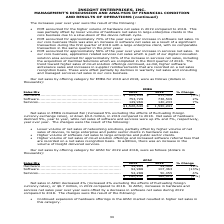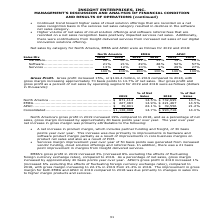From Insight Enterprises's financial document, What is the net sales of hardware in 2019 and 2018 respectively? The document shows two values: $34,965 and $29,496 (in thousands). From the document: "...................................... $ 34,965 $ 29,496 19% Software .................................................................. 92,988 107,36..." Also, What is the net sales of software in 2019 and 2018 respectively? The document shows two values: 92,988 and 107,363 (in thousands). From the document: "................................................. 92,988 107,363 (13%) Services................................................................... 52,..." Also, How much did net sales in decreased in 2019 compared to 2018? According to the financial document, $6.7 million. The relevant text states: "effects of fluctuating foreign currency rates), or $6.7 million, in 2019 compared to 2018. In APAC, increases in hardware and services net sales year over year wer..." Also, can you calculate: What is the change in Sales Mix of Hardware between 2018 and 2019? Based on the calculation: 34,965-29,496, the result is 5469 (in thousands). This is based on the information: "............................................... $ 34,965 $ 29,496 19% Software .................................................................. 92,988 107 ...................................... $ 34..." The key data points involved are: 29,496, 34,965. Also, can you calculate: What is the change in Sales Mix of Software between 2018 and 2019? Based on the calculation: 92,988-107,363, the result is -14375 (in thousands). This is based on the information: "................................................. 92,988 107,363 (13%) Services................................................................... 52,288 50 .......................................... ..." The key data points involved are: 107,363, 92,988. Also, can you calculate: What is the average Sales Mix of Hardware for 2018 and 2019? To answer this question, I need to perform calculations using the financial data. The calculation is: (34,965+29,496) / 2, which equals 32230.5 (in thousands). This is based on the information: "............................................... $ 34,965 $ 29,496 19% Software .................................................................. 92,988 107 ...................................... $ 34..." The key data points involved are: 29,496, 34,965. 